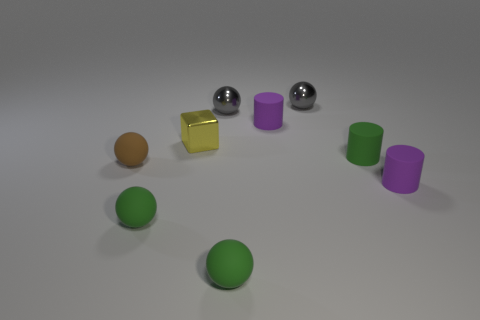What is the size of the ball that is on the right side of the tiny yellow block and in front of the yellow metallic thing?
Your answer should be very brief. Small. Is the number of tiny gray objects that are on the right side of the tiny yellow block less than the number of purple matte objects to the left of the green cylinder?
Your response must be concise. No. Do the tiny green ball that is to the right of the tiny block and the cylinder that is behind the yellow thing have the same material?
Give a very brief answer. Yes. There is a tiny thing that is both in front of the yellow metal thing and behind the tiny brown sphere; what shape is it?
Provide a succinct answer. Cylinder. There is a purple cylinder in front of the small purple rubber cylinder behind the block; what is its material?
Make the answer very short. Rubber. Are there more brown rubber spheres than tiny gray things?
Offer a terse response. No. There is a yellow object that is the same size as the green matte cylinder; what is it made of?
Ensure brevity in your answer.  Metal. Is the small yellow thing made of the same material as the small brown sphere?
Offer a very short reply. No. What number of tiny green cylinders have the same material as the tiny brown sphere?
Offer a very short reply. 1. What number of things are small green matte things on the left side of the yellow cube or purple rubber cylinders that are behind the tiny green rubber cylinder?
Your response must be concise. 2. 